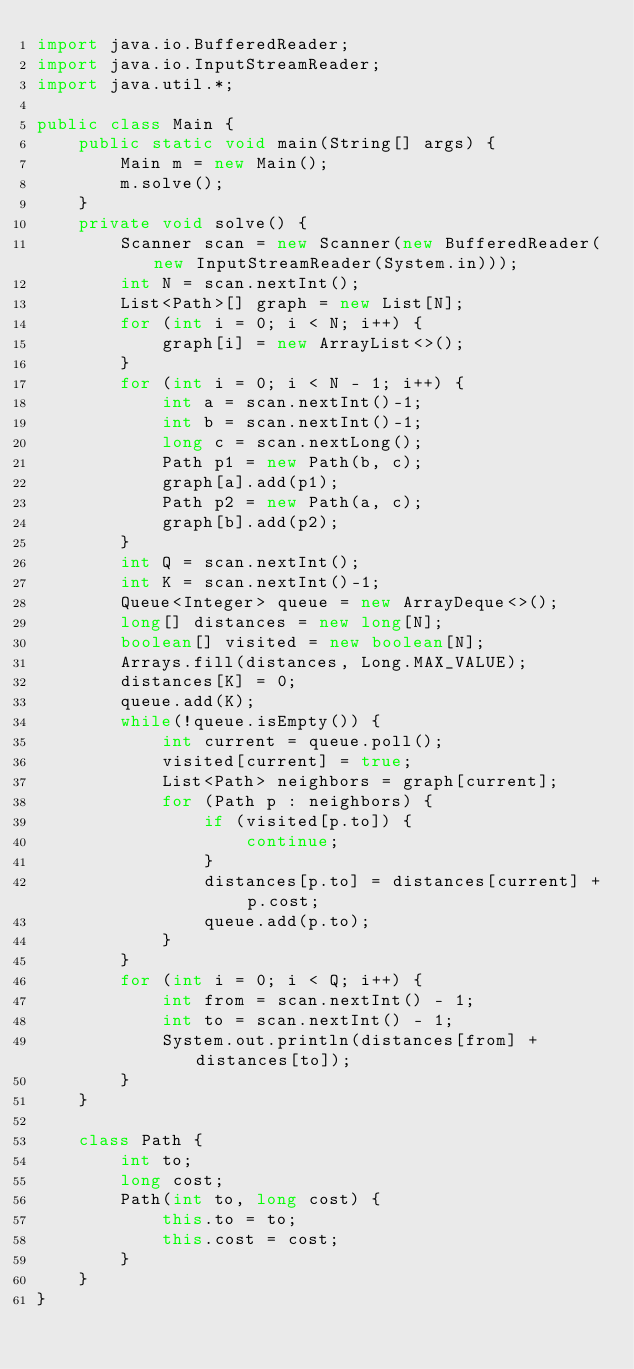<code> <loc_0><loc_0><loc_500><loc_500><_Java_>import java.io.BufferedReader;
import java.io.InputStreamReader;
import java.util.*;

public class Main {
    public static void main(String[] args) {
        Main m = new Main();
        m.solve();
    }
    private void solve() {
        Scanner scan = new Scanner(new BufferedReader(new InputStreamReader(System.in)));
        int N = scan.nextInt();
        List<Path>[] graph = new List[N];
        for (int i = 0; i < N; i++) {
            graph[i] = new ArrayList<>();
        }
        for (int i = 0; i < N - 1; i++) {
            int a = scan.nextInt()-1;
            int b = scan.nextInt()-1;
            long c = scan.nextLong();
            Path p1 = new Path(b, c);
            graph[a].add(p1);
            Path p2 = new Path(a, c);
            graph[b].add(p2);
        }
        int Q = scan.nextInt();
        int K = scan.nextInt()-1;
        Queue<Integer> queue = new ArrayDeque<>();
        long[] distances = new long[N];
        boolean[] visited = new boolean[N];
        Arrays.fill(distances, Long.MAX_VALUE);
        distances[K] = 0;
        queue.add(K);
        while(!queue.isEmpty()) {
            int current = queue.poll();
            visited[current] = true;
            List<Path> neighbors = graph[current];
            for (Path p : neighbors) {
                if (visited[p.to]) {
                    continue;
                }
                distances[p.to] = distances[current] + p.cost;
                queue.add(p.to);
            }
        }
        for (int i = 0; i < Q; i++) {
            int from = scan.nextInt() - 1;
            int to = scan.nextInt() - 1;
            System.out.println(distances[from] + distances[to]);
        }
    }

    class Path {
        int to;
        long cost;
        Path(int to, long cost) {
            this.to = to;
            this.cost = cost;
        }
    }
}
</code> 